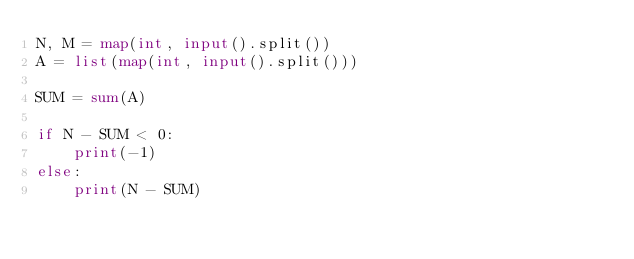<code> <loc_0><loc_0><loc_500><loc_500><_Python_>N, M = map(int, input().split())
A = list(map(int, input().split()))

SUM = sum(A)

if N - SUM < 0:
    print(-1)
else:
    print(N - SUM)</code> 